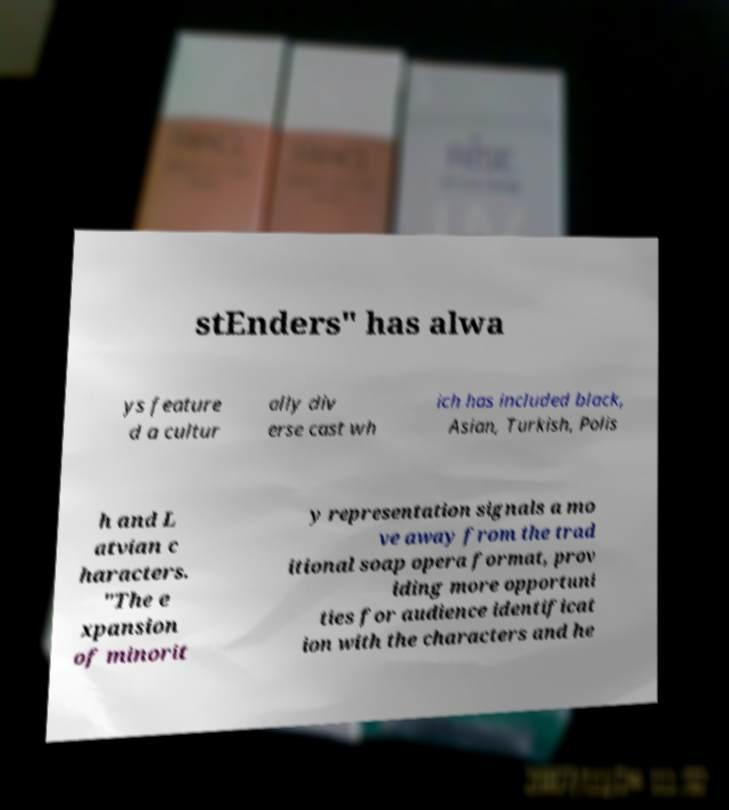Can you read and provide the text displayed in the image?This photo seems to have some interesting text. Can you extract and type it out for me? stEnders" has alwa ys feature d a cultur ally div erse cast wh ich has included black, Asian, Turkish, Polis h and L atvian c haracters. "The e xpansion of minorit y representation signals a mo ve away from the trad itional soap opera format, prov iding more opportuni ties for audience identificat ion with the characters and he 